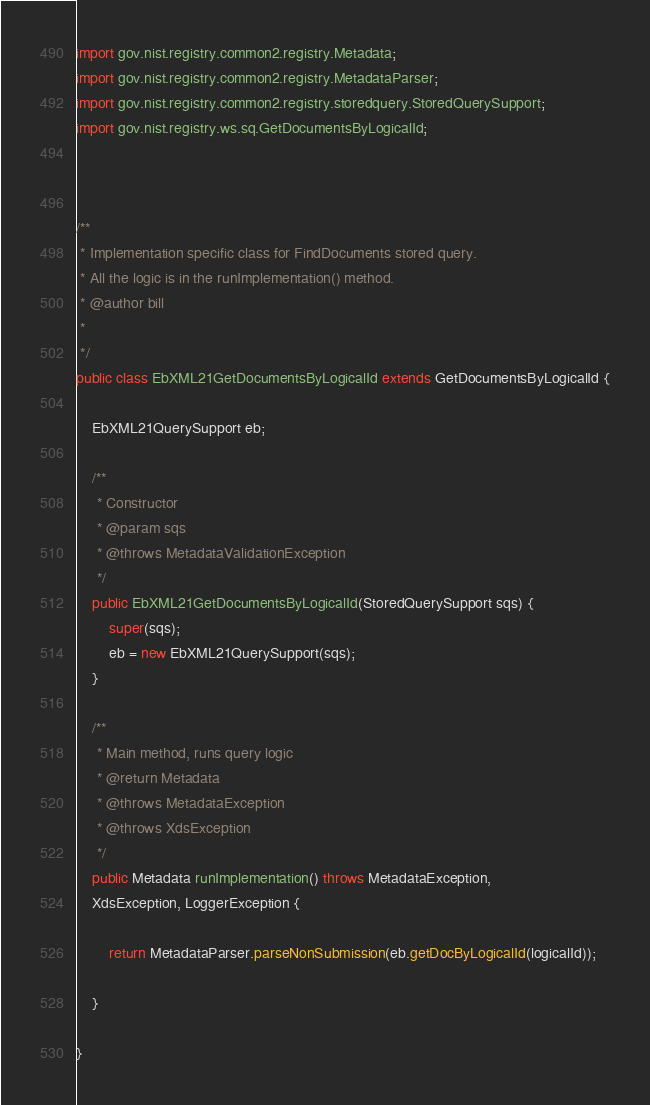<code> <loc_0><loc_0><loc_500><loc_500><_Java_>import gov.nist.registry.common2.registry.Metadata;
import gov.nist.registry.common2.registry.MetadataParser;
import gov.nist.registry.common2.registry.storedquery.StoredQuerySupport;
import gov.nist.registry.ws.sq.GetDocumentsByLogicalId;



/**
 * Implementation specific class for FindDocuments stored query. 
 * All the logic is in the runImplementation() method.
 * @author bill
 *
 */
public class EbXML21GetDocumentsByLogicalId extends GetDocumentsByLogicalId {

	EbXML21QuerySupport eb;

	/**
	 * Constructor
	 * @param sqs
	 * @throws MetadataValidationException
	 */
	public EbXML21GetDocumentsByLogicalId(StoredQuerySupport sqs) {
		super(sqs);
		eb = new EbXML21QuerySupport(sqs);
	}

	/**
	 * Main method, runs query logic
	 * @return Metadata
	 * @throws MetadataException
	 * @throws XdsException
	 */
	public Metadata runImplementation() throws MetadataException,
	XdsException, LoggerException {
		
		return MetadataParser.parseNonSubmission(eb.getDocByLogicalId(logicalId));

	}

}
</code> 